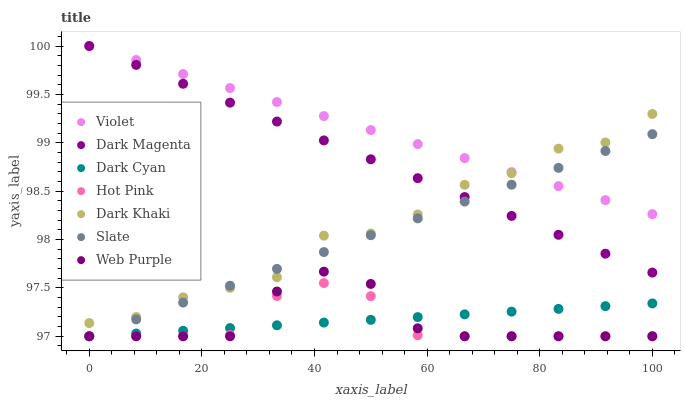Does Hot Pink have the minimum area under the curve?
Answer yes or no. Yes. Does Violet have the maximum area under the curve?
Answer yes or no. Yes. Does Slate have the minimum area under the curve?
Answer yes or no. No. Does Slate have the maximum area under the curve?
Answer yes or no. No. Is Violet the smoothest?
Answer yes or no. Yes. Is Dark Khaki the roughest?
Answer yes or no. Yes. Is Slate the smoothest?
Answer yes or no. No. Is Slate the roughest?
Answer yes or no. No. Does Slate have the lowest value?
Answer yes or no. Yes. Does Dark Khaki have the lowest value?
Answer yes or no. No. Does Violet have the highest value?
Answer yes or no. Yes. Does Slate have the highest value?
Answer yes or no. No. Is Hot Pink less than Violet?
Answer yes or no. Yes. Is Violet greater than Hot Pink?
Answer yes or no. Yes. Does Hot Pink intersect Web Purple?
Answer yes or no. Yes. Is Hot Pink less than Web Purple?
Answer yes or no. No. Is Hot Pink greater than Web Purple?
Answer yes or no. No. Does Hot Pink intersect Violet?
Answer yes or no. No. 